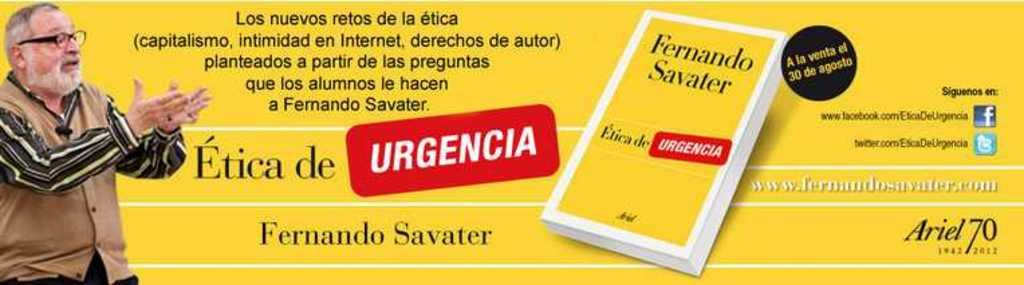Provide a one-sentence caption for the provided image. A book by Ferndando Savater called Etica de Urgencia. 